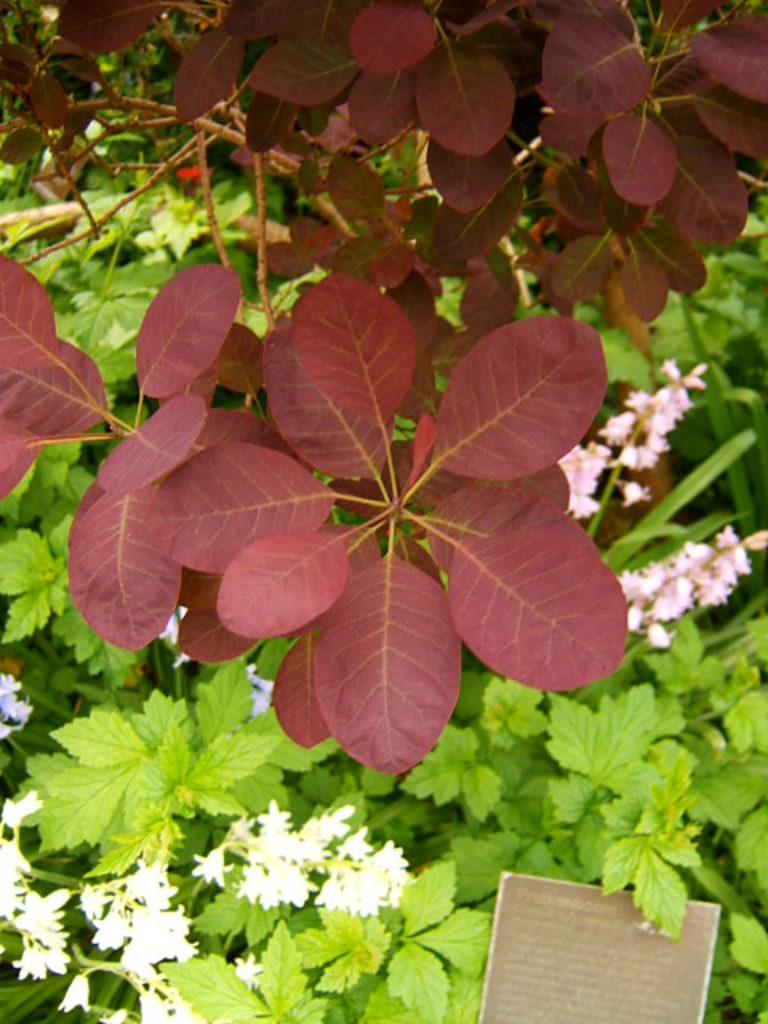What type of vegetation can be seen in the front of the image? There are red leaves in the front of the image. What can be seen in the background of the image? There are flowers and plants in the background of the image. Can you describe the object with text written on it in the image? Unfortunately, the facts provided do not give enough information to describe the object with text written on it. How does the crowd react to the thrilling event in the image? There is no crowd or thrilling event present in the image; it features red leaves in the front and flowers and plants in the background. 